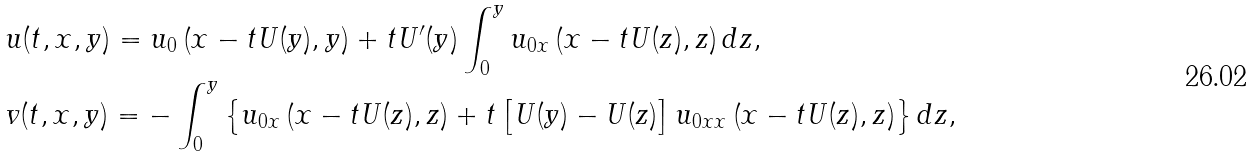<formula> <loc_0><loc_0><loc_500><loc_500>& u ( t , x , y ) = u _ { 0 } \left ( x - t U ( y ) , y \right ) + t U ^ { \prime } ( y ) \int _ { 0 } ^ { y } u _ { 0 x } \left ( x - t U ( z ) , z \right ) d z , \\ & v ( t , x , y ) = - \int _ { 0 } ^ { y } \left \{ u _ { 0 x } \left ( x - t U ( z ) , z \right ) + t \left [ U ( y ) - U ( z ) \right ] u _ { 0 x x } \left ( x - t U ( z ) , z \right ) \right \} d z ,</formula> 